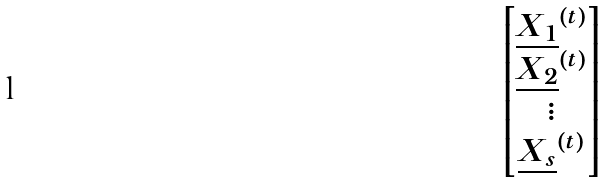Convert formula to latex. <formula><loc_0><loc_0><loc_500><loc_500>\begin{bmatrix} \underline { X _ { 1 } } ^ { ( t ) } \\ \underline { X _ { 2 } } ^ { ( t ) } \\ \vdots \\ \underline { X _ { s } } ^ { ( t ) } \\ \end{bmatrix}</formula> 